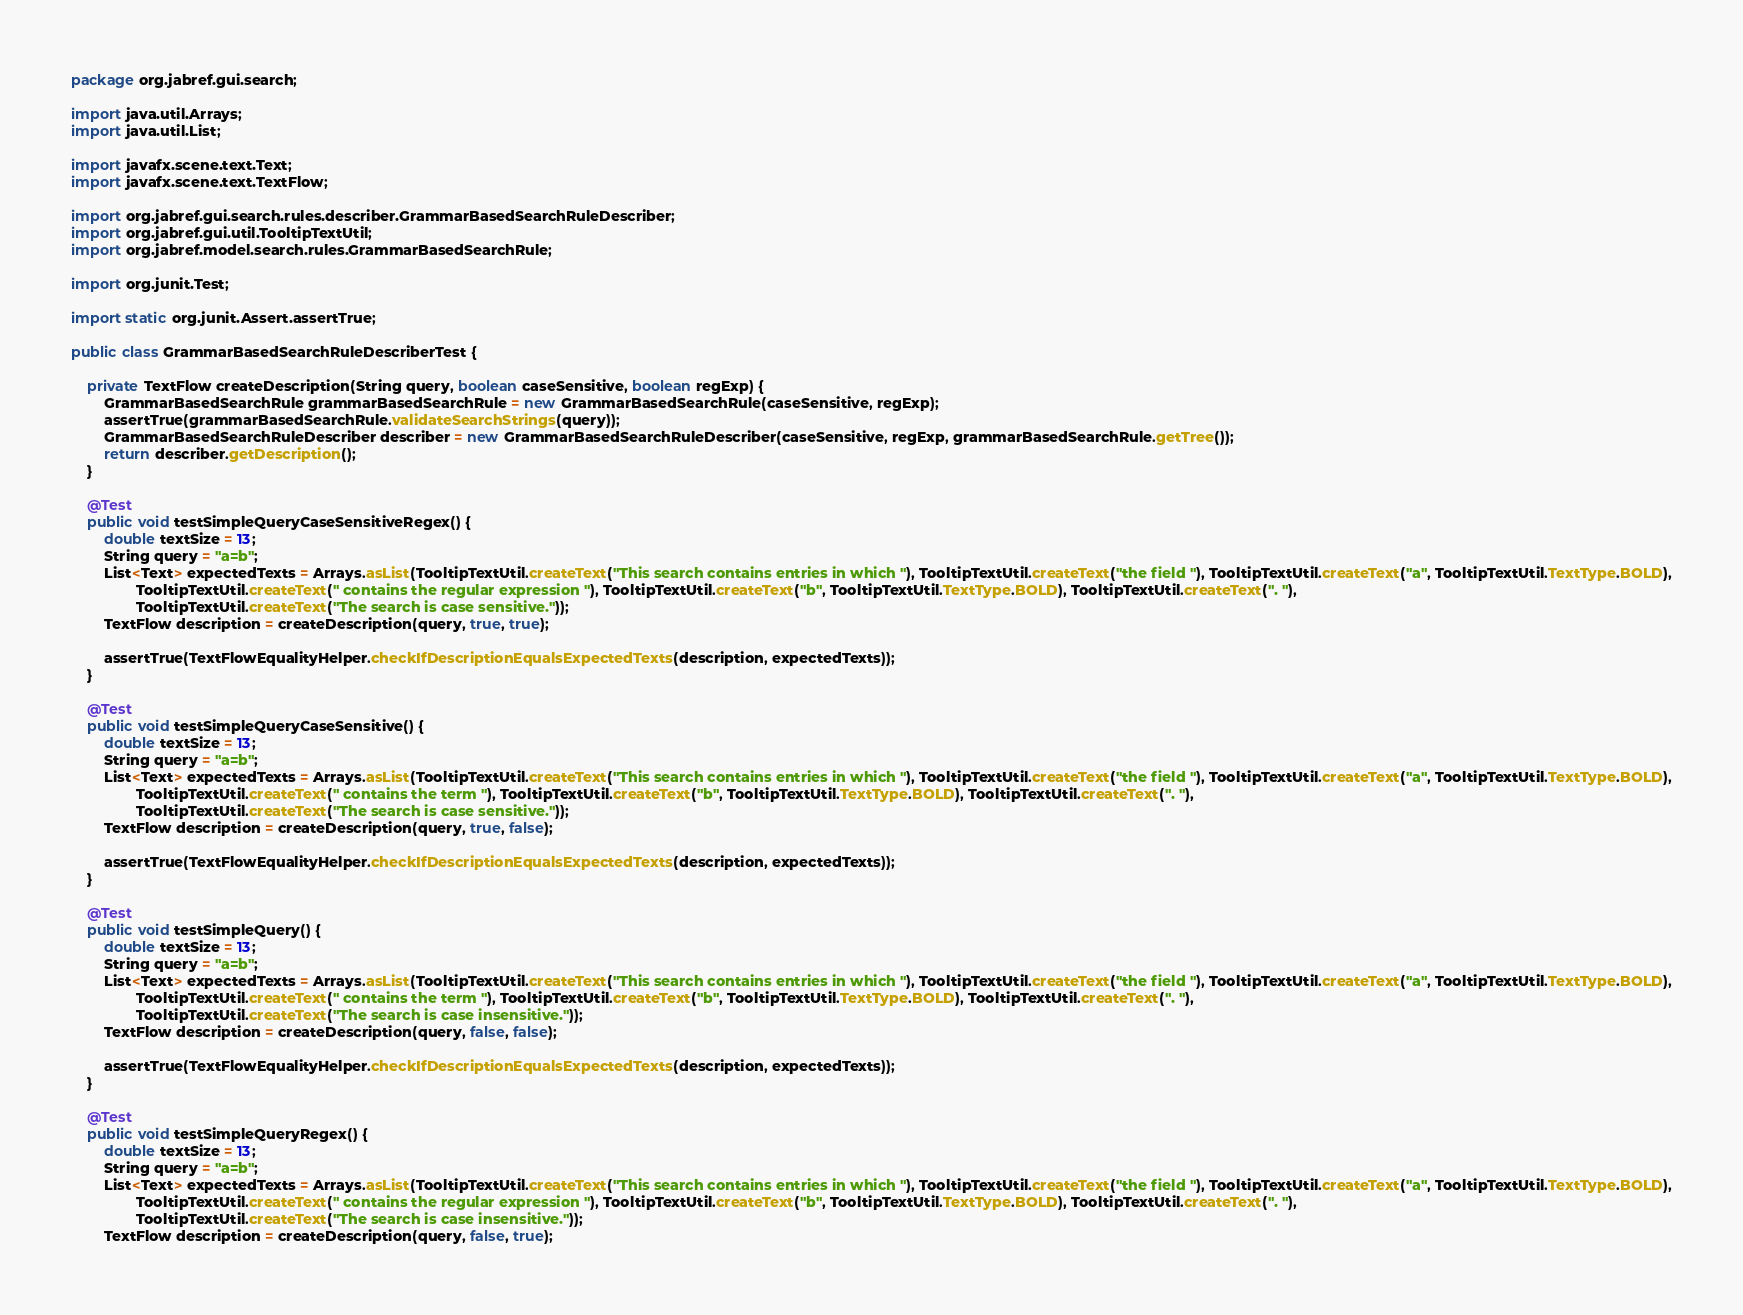Convert code to text. <code><loc_0><loc_0><loc_500><loc_500><_Java_>package org.jabref.gui.search;

import java.util.Arrays;
import java.util.List;

import javafx.scene.text.Text;
import javafx.scene.text.TextFlow;

import org.jabref.gui.search.rules.describer.GrammarBasedSearchRuleDescriber;
import org.jabref.gui.util.TooltipTextUtil;
import org.jabref.model.search.rules.GrammarBasedSearchRule;

import org.junit.Test;

import static org.junit.Assert.assertTrue;

public class GrammarBasedSearchRuleDescriberTest {

    private TextFlow createDescription(String query, boolean caseSensitive, boolean regExp) {
        GrammarBasedSearchRule grammarBasedSearchRule = new GrammarBasedSearchRule(caseSensitive, regExp);
        assertTrue(grammarBasedSearchRule.validateSearchStrings(query));
        GrammarBasedSearchRuleDescriber describer = new GrammarBasedSearchRuleDescriber(caseSensitive, regExp, grammarBasedSearchRule.getTree());
        return describer.getDescription();
    }

    @Test
    public void testSimpleQueryCaseSensitiveRegex() {
        double textSize = 13;
        String query = "a=b";
        List<Text> expectedTexts = Arrays.asList(TooltipTextUtil.createText("This search contains entries in which "), TooltipTextUtil.createText("the field "), TooltipTextUtil.createText("a", TooltipTextUtil.TextType.BOLD),
                TooltipTextUtil.createText(" contains the regular expression "), TooltipTextUtil.createText("b", TooltipTextUtil.TextType.BOLD), TooltipTextUtil.createText(". "),
                TooltipTextUtil.createText("The search is case sensitive."));
        TextFlow description = createDescription(query, true, true);

        assertTrue(TextFlowEqualityHelper.checkIfDescriptionEqualsExpectedTexts(description, expectedTexts));
    }

    @Test
    public void testSimpleQueryCaseSensitive() {
        double textSize = 13;
        String query = "a=b";
        List<Text> expectedTexts = Arrays.asList(TooltipTextUtil.createText("This search contains entries in which "), TooltipTextUtil.createText("the field "), TooltipTextUtil.createText("a", TooltipTextUtil.TextType.BOLD),
                TooltipTextUtil.createText(" contains the term "), TooltipTextUtil.createText("b", TooltipTextUtil.TextType.BOLD), TooltipTextUtil.createText(". "),
                TooltipTextUtil.createText("The search is case sensitive."));
        TextFlow description = createDescription(query, true, false);

        assertTrue(TextFlowEqualityHelper.checkIfDescriptionEqualsExpectedTexts(description, expectedTexts));
    }

    @Test
    public void testSimpleQuery() {
        double textSize = 13;
        String query = "a=b";
        List<Text> expectedTexts = Arrays.asList(TooltipTextUtil.createText("This search contains entries in which "), TooltipTextUtil.createText("the field "), TooltipTextUtil.createText("a", TooltipTextUtil.TextType.BOLD),
                TooltipTextUtil.createText(" contains the term "), TooltipTextUtil.createText("b", TooltipTextUtil.TextType.BOLD), TooltipTextUtil.createText(". "),
                TooltipTextUtil.createText("The search is case insensitive."));
        TextFlow description = createDescription(query, false, false);

        assertTrue(TextFlowEqualityHelper.checkIfDescriptionEqualsExpectedTexts(description, expectedTexts));
    }

    @Test
    public void testSimpleQueryRegex() {
        double textSize = 13;
        String query = "a=b";
        List<Text> expectedTexts = Arrays.asList(TooltipTextUtil.createText("This search contains entries in which "), TooltipTextUtil.createText("the field "), TooltipTextUtil.createText("a", TooltipTextUtil.TextType.BOLD),
                TooltipTextUtil.createText(" contains the regular expression "), TooltipTextUtil.createText("b", TooltipTextUtil.TextType.BOLD), TooltipTextUtil.createText(". "),
                TooltipTextUtil.createText("The search is case insensitive."));
        TextFlow description = createDescription(query, false, true);
</code> 